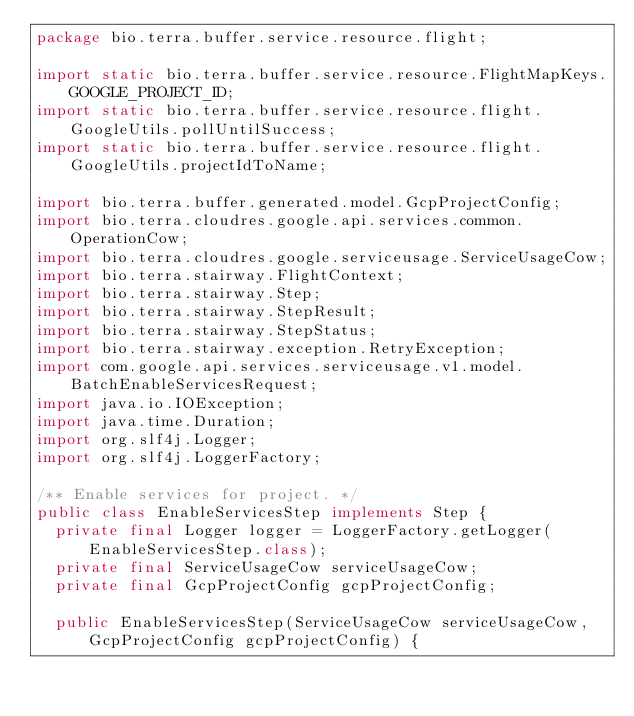Convert code to text. <code><loc_0><loc_0><loc_500><loc_500><_Java_>package bio.terra.buffer.service.resource.flight;

import static bio.terra.buffer.service.resource.FlightMapKeys.GOOGLE_PROJECT_ID;
import static bio.terra.buffer.service.resource.flight.GoogleUtils.pollUntilSuccess;
import static bio.terra.buffer.service.resource.flight.GoogleUtils.projectIdToName;

import bio.terra.buffer.generated.model.GcpProjectConfig;
import bio.terra.cloudres.google.api.services.common.OperationCow;
import bio.terra.cloudres.google.serviceusage.ServiceUsageCow;
import bio.terra.stairway.FlightContext;
import bio.terra.stairway.Step;
import bio.terra.stairway.StepResult;
import bio.terra.stairway.StepStatus;
import bio.terra.stairway.exception.RetryException;
import com.google.api.services.serviceusage.v1.model.BatchEnableServicesRequest;
import java.io.IOException;
import java.time.Duration;
import org.slf4j.Logger;
import org.slf4j.LoggerFactory;

/** Enable services for project. */
public class EnableServicesStep implements Step {
  private final Logger logger = LoggerFactory.getLogger(EnableServicesStep.class);
  private final ServiceUsageCow serviceUsageCow;
  private final GcpProjectConfig gcpProjectConfig;

  public EnableServicesStep(ServiceUsageCow serviceUsageCow, GcpProjectConfig gcpProjectConfig) {</code> 